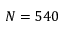<formula> <loc_0><loc_0><loc_500><loc_500>N = 5 4 0</formula> 